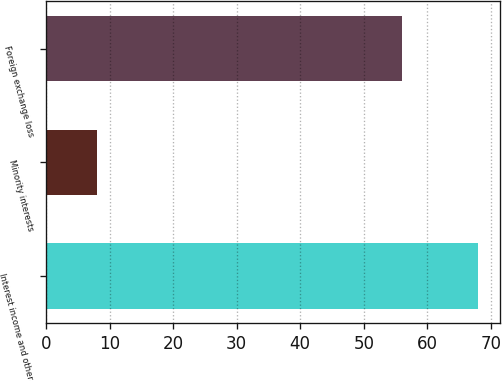<chart> <loc_0><loc_0><loc_500><loc_500><bar_chart><fcel>Interest income and other<fcel>Minority interests<fcel>Foreign exchange loss<nl><fcel>68<fcel>8<fcel>56<nl></chart> 